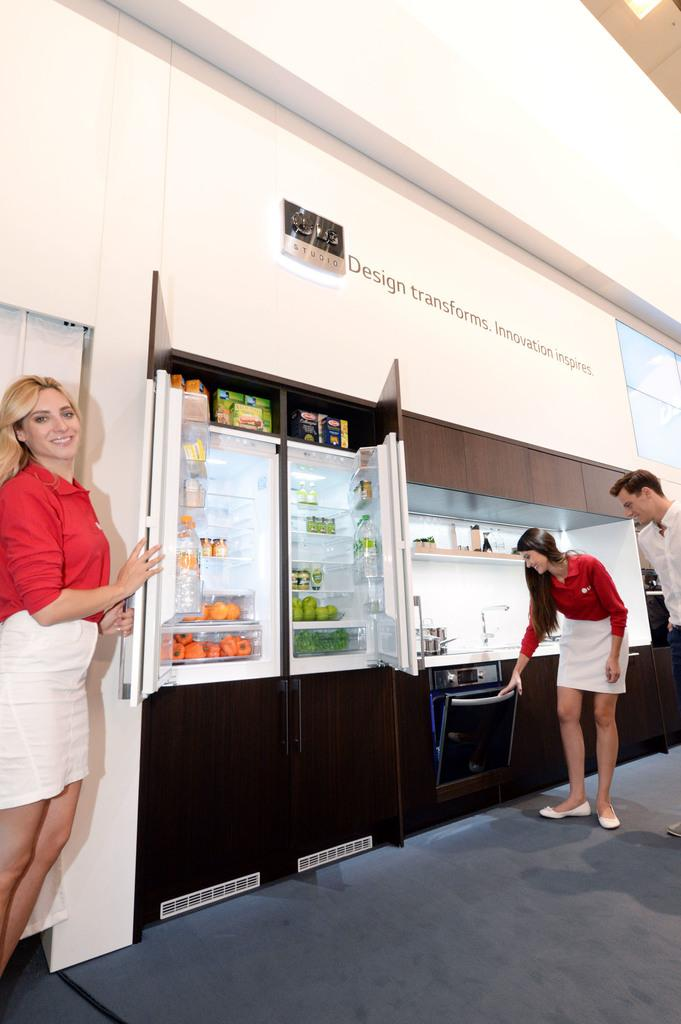<image>
Summarize the visual content of the image. A mock kitchen setup with the words Design transform on the top. 